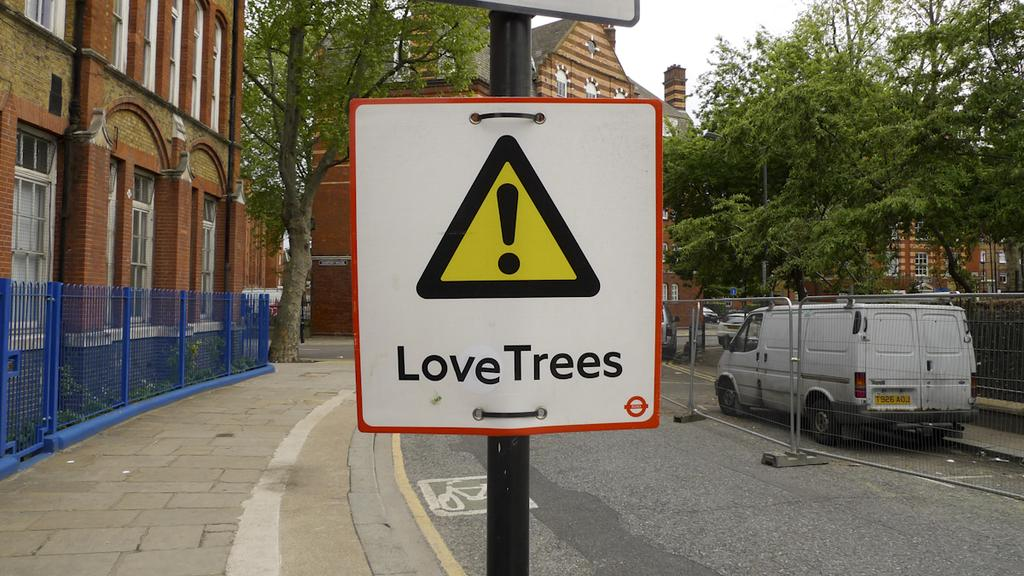<image>
Present a compact description of the photo's key features. A sign with an exclamation point inside a yellow triangle, that says love trees is secured to a street sign pole. 